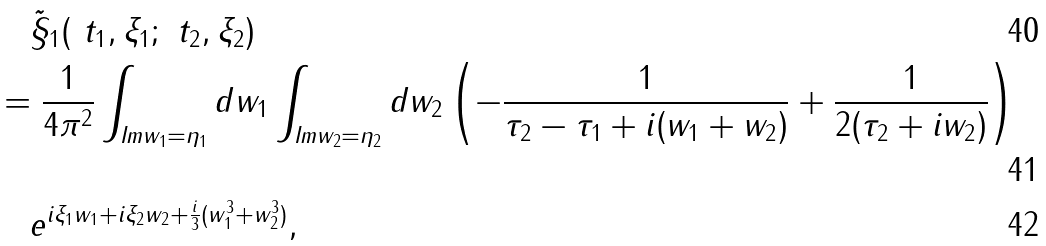<formula> <loc_0><loc_0><loc_500><loc_500>& \quad \tilde { \S } _ { 1 } ( \ t _ { 1 } , \xi _ { 1 } ; \ t _ { 2 } , \xi _ { 2 } ) \\ & = \frac { 1 } { 4 \pi ^ { 2 } } \int _ { \text {Im} w _ { 1 } = \eta _ { 1 } } d w _ { 1 } \int _ { \text {Im} w _ { 2 } = \eta _ { 2 } } d w _ { 2 } \left ( - \frac { 1 } { \tau _ { 2 } - \tau _ { 1 } + i ( w _ { 1 } + w _ { 2 } ) } + \frac { 1 } { 2 ( \tau _ { 2 } + i w _ { 2 } ) } \right ) \\ & \quad e ^ { i \xi _ { 1 } w _ { 1 } + i \xi _ { 2 } w _ { 2 } + \frac { i } { 3 } ( w _ { 1 } ^ { 3 } + w _ { 2 } ^ { 3 } ) } ,</formula> 